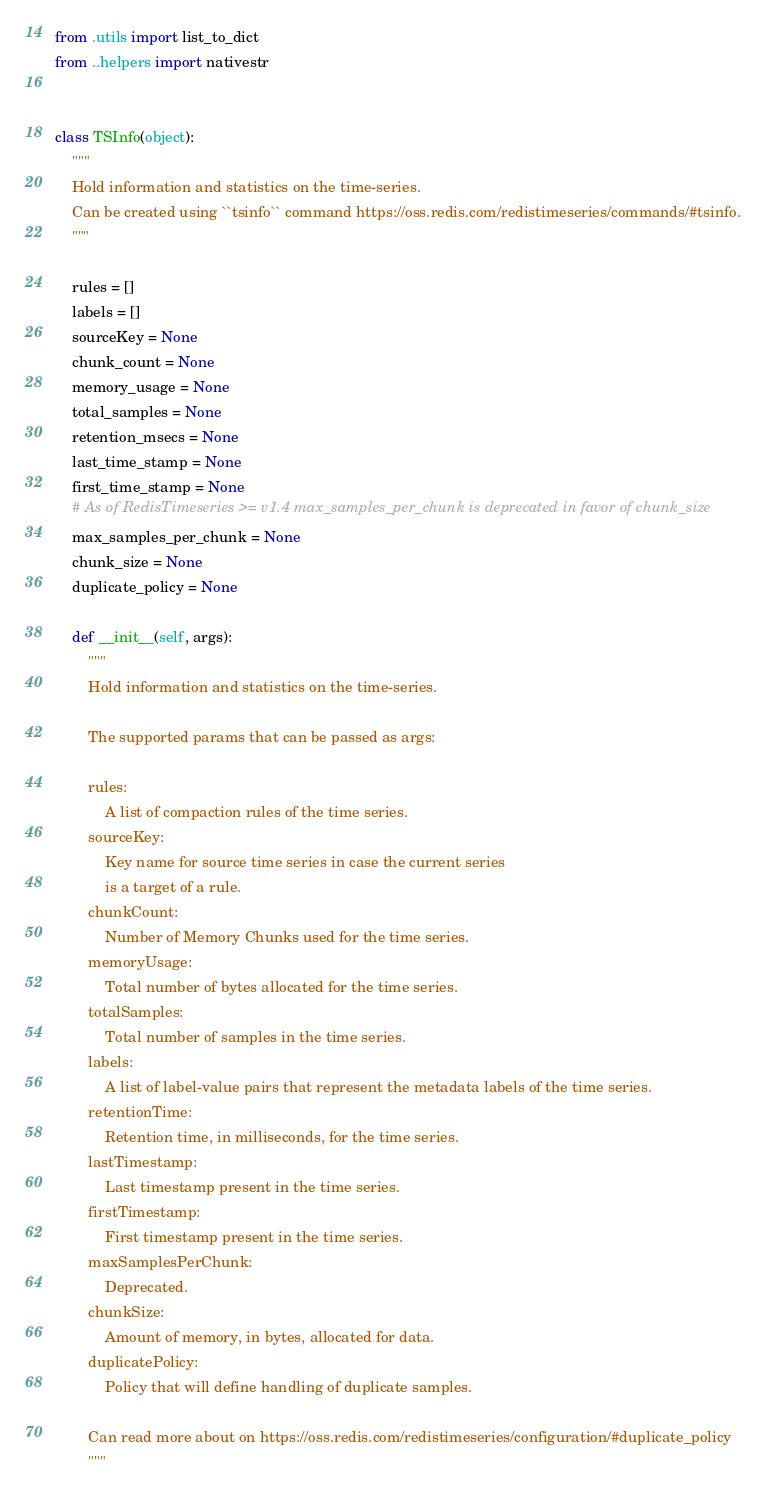Convert code to text. <code><loc_0><loc_0><loc_500><loc_500><_Python_>from .utils import list_to_dict
from ..helpers import nativestr


class TSInfo(object):
    """
    Hold information and statistics on the time-series.
    Can be created using ``tsinfo`` command https://oss.redis.com/redistimeseries/commands/#tsinfo.
    """

    rules = []
    labels = []
    sourceKey = None
    chunk_count = None
    memory_usage = None
    total_samples = None
    retention_msecs = None
    last_time_stamp = None
    first_time_stamp = None
    # As of RedisTimeseries >= v1.4 max_samples_per_chunk is deprecated in favor of chunk_size
    max_samples_per_chunk = None
    chunk_size = None
    duplicate_policy = None

    def __init__(self, args):
        """
        Hold information and statistics on the time-series.

        The supported params that can be passed as args:

        rules:
            A list of compaction rules of the time series.
        sourceKey:
            Key name for source time series in case the current series
            is a target of a rule.
        chunkCount:
            Number of Memory Chunks used for the time series.
        memoryUsage:
            Total number of bytes allocated for the time series.
        totalSamples:
            Total number of samples in the time series.
        labels:
            A list of label-value pairs that represent the metadata labels of the time series.
        retentionTime:
            Retention time, in milliseconds, for the time series.
        lastTimestamp:
            Last timestamp present in the time series.
        firstTimestamp:
            First timestamp present in the time series.
        maxSamplesPerChunk:
            Deprecated.
        chunkSize:
            Amount of memory, in bytes, allocated for data.
        duplicatePolicy:
            Policy that will define handling of duplicate samples.

        Can read more about on https://oss.redis.com/redistimeseries/configuration/#duplicate_policy
        """</code> 